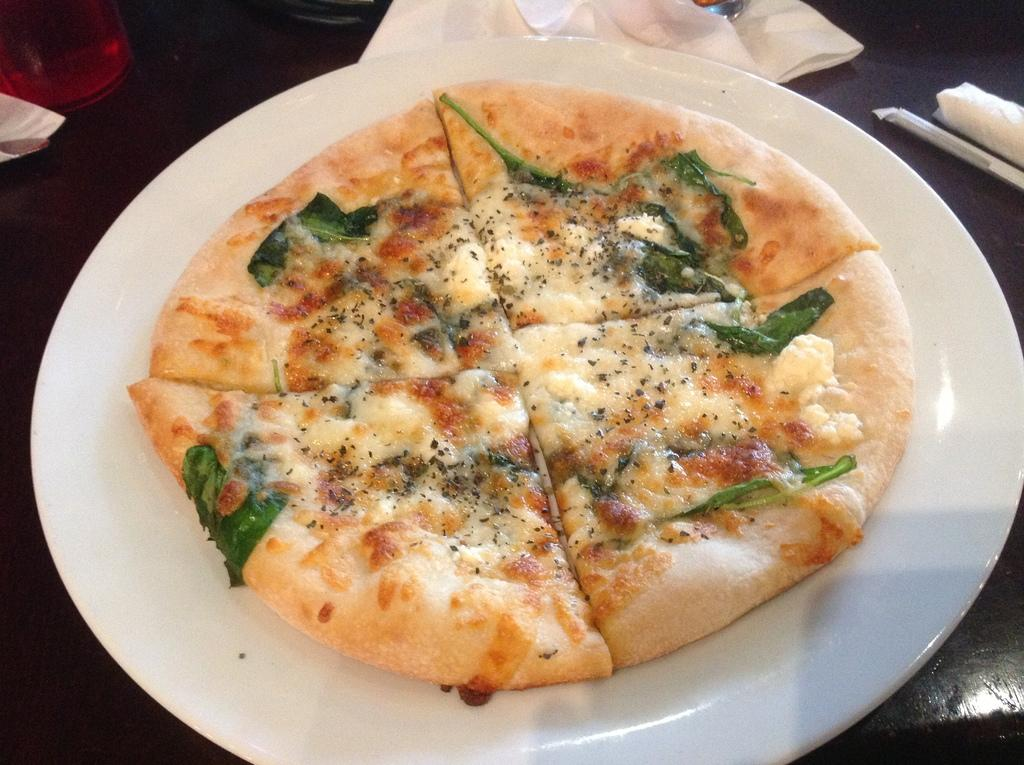What piece of furniture is visible in the image? There is a table in the image. What is placed on the table? A plate, a bottle, and tissue papers are placed on the table. What type of food is on the plate? There is pizza on the plate. What might be used for cleaning or wiping in the image? Tissue papers are present on the table for cleaning or wiping. What type of lettuce is visible on the pizza in the image? There is no lettuce visible on the pizza in the image. How many visitors are present in the image? There is no indication of any visitors in the image. 